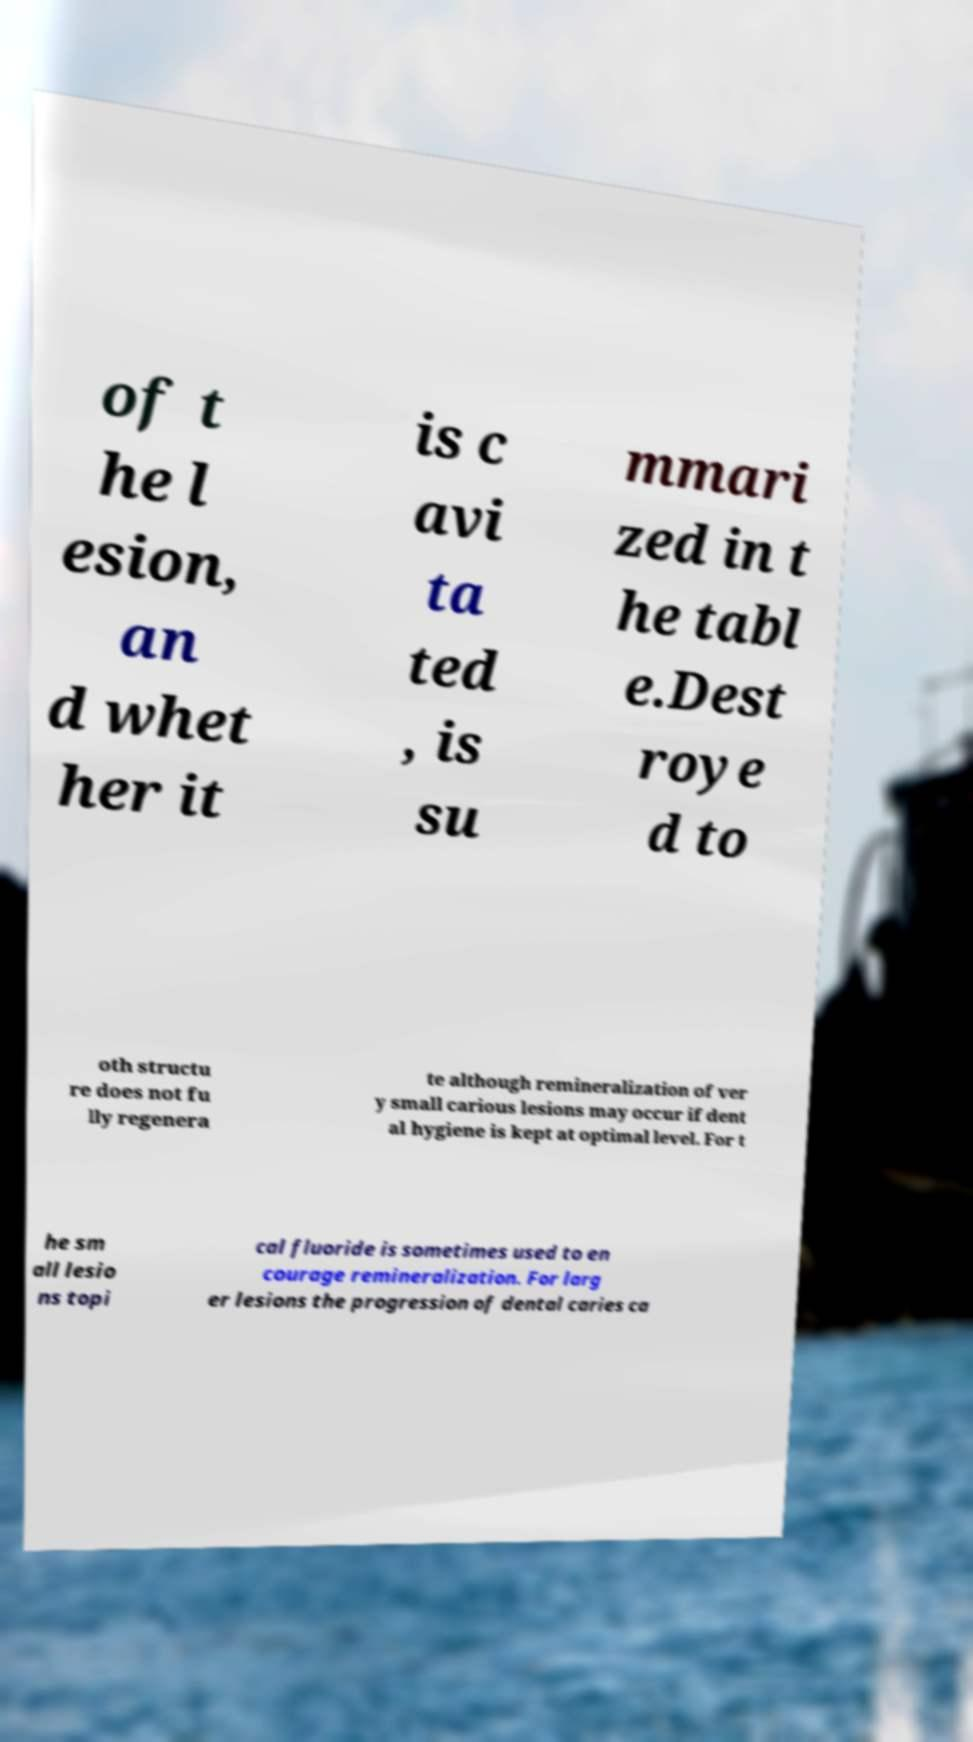Can you accurately transcribe the text from the provided image for me? of t he l esion, an d whet her it is c avi ta ted , is su mmari zed in t he tabl e.Dest roye d to oth structu re does not fu lly regenera te although remineralization of ver y small carious lesions may occur if dent al hygiene is kept at optimal level. For t he sm all lesio ns topi cal fluoride is sometimes used to en courage remineralization. For larg er lesions the progression of dental caries ca 